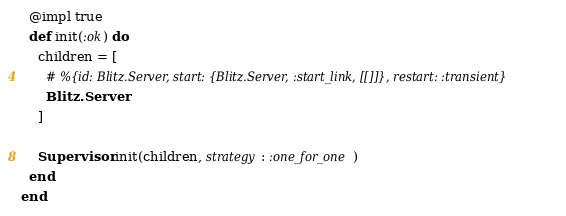<code> <loc_0><loc_0><loc_500><loc_500><_Elixir_>
  @impl true
  def init(:ok) do
    children = [
      # %{id: Blitz.Server, start: {Blitz.Server, :start_link, [[]]}, restart: :transient}
      Blitz.Server
    ]

    Supervisor.init(children, strategy: :one_for_one)
  end
end
</code> 